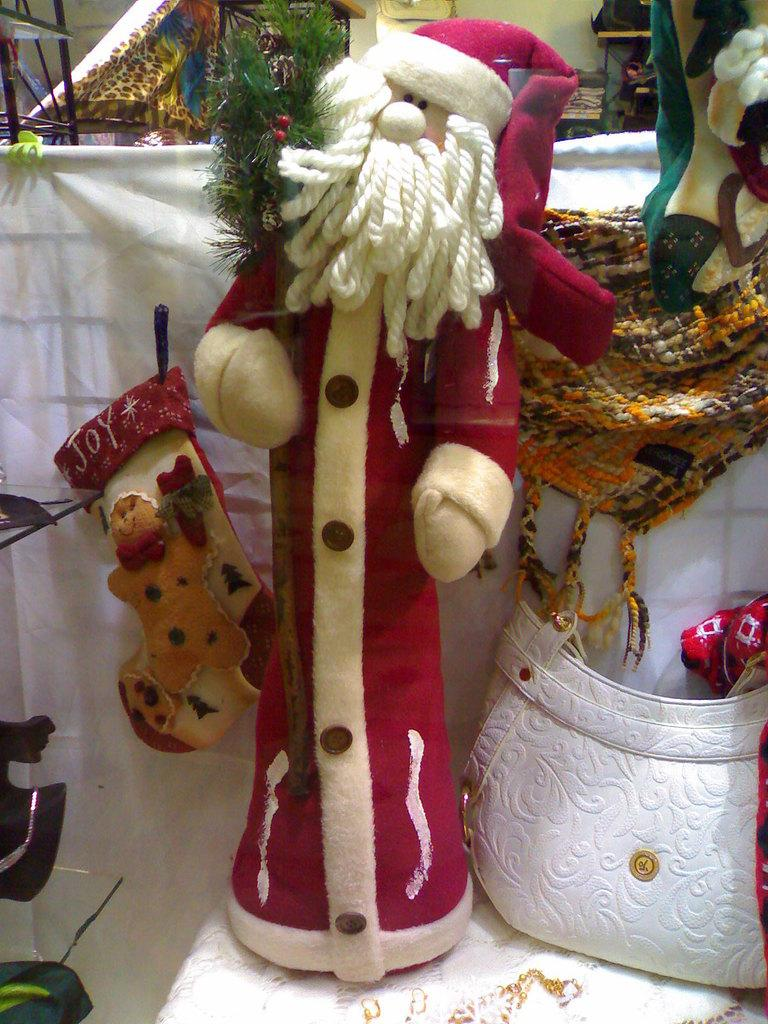What objects are present in the image? There are toys in the image. Can you describe the location of the bag in the image? The bag is on the right side of the image. How many ants can be seen crawling on the toys in the image? There are no ants present in the image; it only features toys and a bag. What type of stream is visible in the image? There is no stream present in the image. 